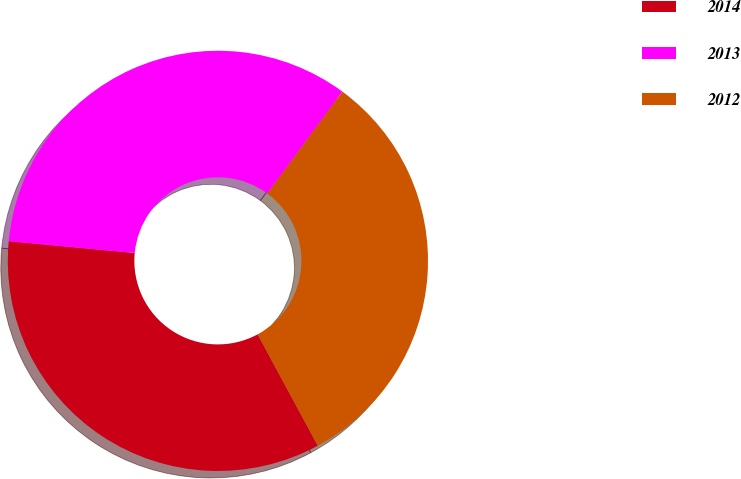<chart> <loc_0><loc_0><loc_500><loc_500><pie_chart><fcel>2014<fcel>2013<fcel>2012<nl><fcel>34.38%<fcel>33.6%<fcel>32.02%<nl></chart> 